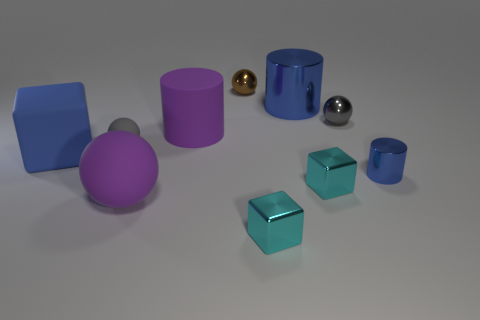There is a small metal cylinder; does it have the same color as the metal cylinder behind the blue matte cube?
Keep it short and to the point. Yes. What number of big matte things are the same color as the big ball?
Offer a terse response. 1. How many other objects are there of the same color as the big matte cube?
Make the answer very short. 2. What number of cylinders are behind the purple matte cylinder and on the left side of the brown metal sphere?
Your response must be concise. 0. Are there more tiny gray objects that are left of the tiny gray metal object than cylinders that are behind the big matte block?
Your answer should be compact. No. What is the gray ball to the left of the big metallic thing made of?
Provide a short and direct response. Rubber. There is a big metallic thing; is it the same shape as the small thing that is right of the small gray shiny ball?
Ensure brevity in your answer.  Yes. There is a cyan block to the left of the large blue thing that is on the right side of the gray rubber ball; how many blue objects are left of it?
Ensure brevity in your answer.  1. There is another metallic thing that is the same shape as the tiny blue object; what color is it?
Give a very brief answer. Blue. How many cubes are either big gray metallic objects or tiny cyan metallic objects?
Provide a short and direct response. 2. 